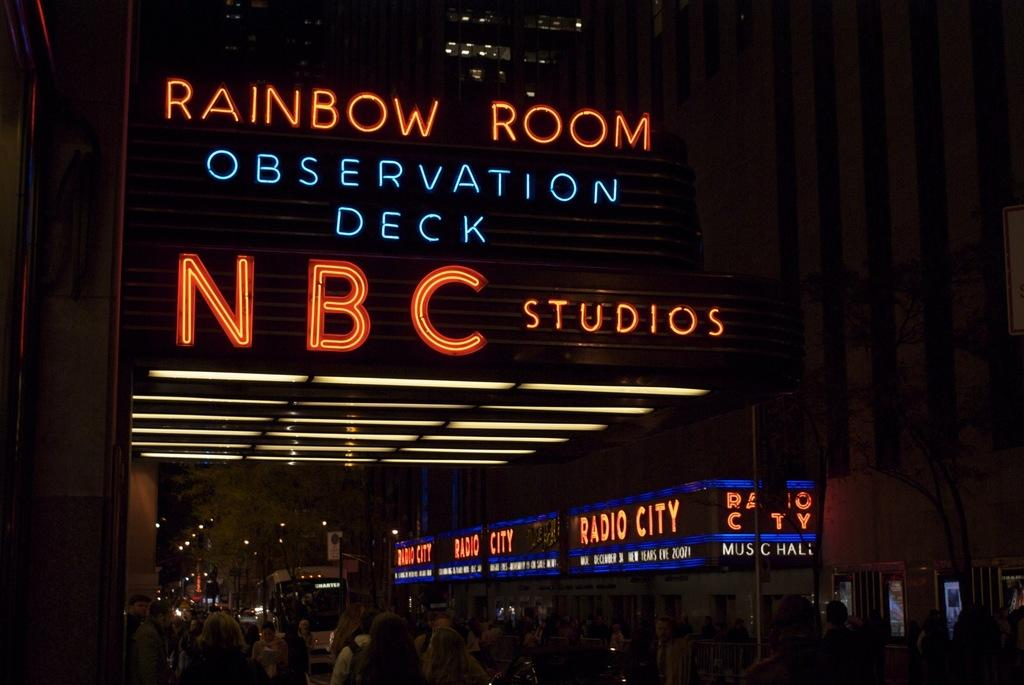What type of lights are on the building in the image? There are text lights on the building. Can you describe the people at the bottom of the image? Unfortunately, the provided facts do not give any information about the people at the bottom of the image. What type of mint is being used to decorate the text lights on the building? There is no mention of mint or any decoration in the provided facts, so we cannot answer this question. 